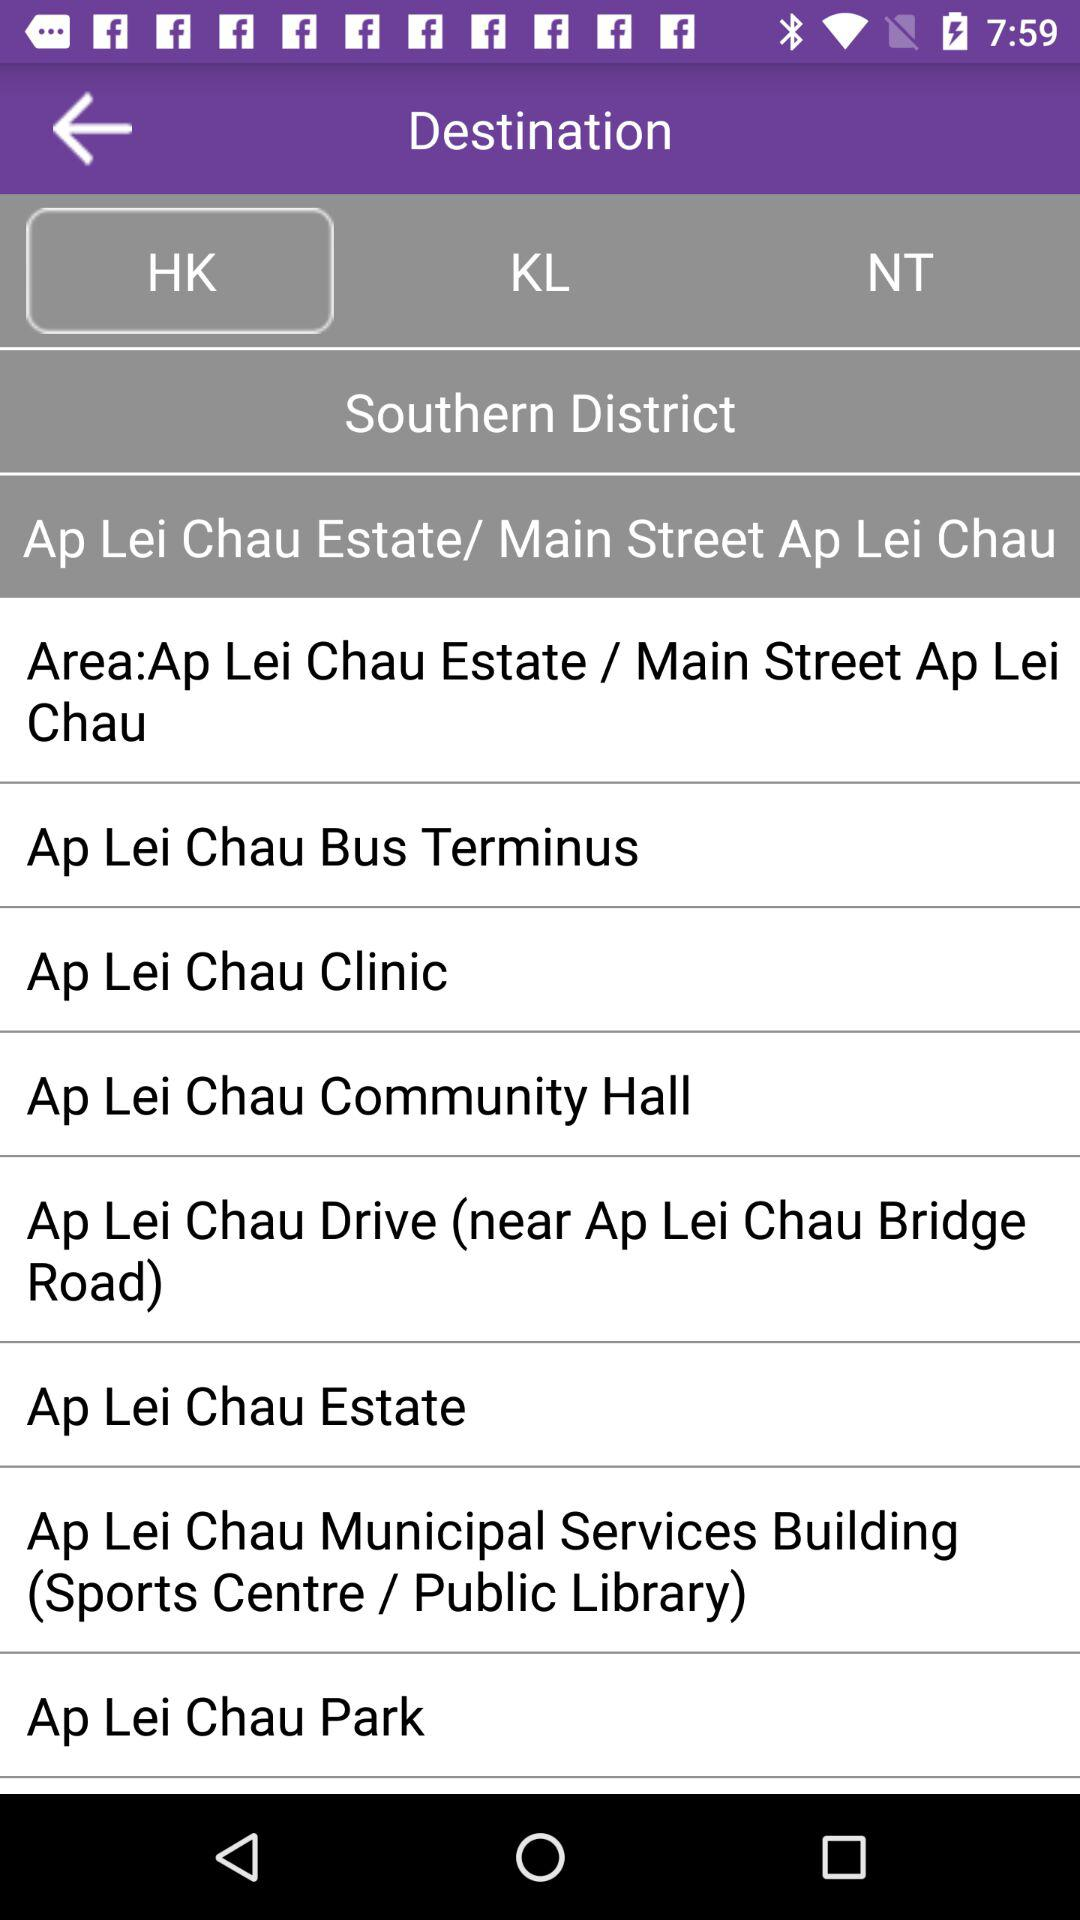Which tab is selected? The selected tab is "HK". 